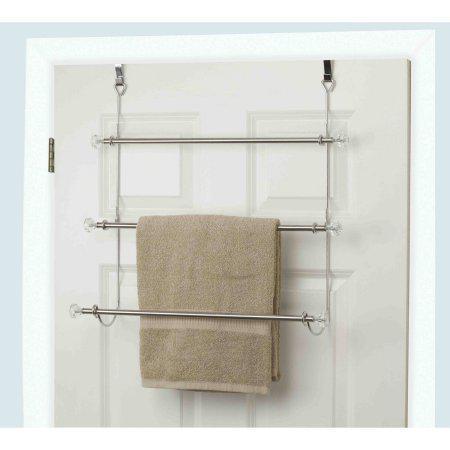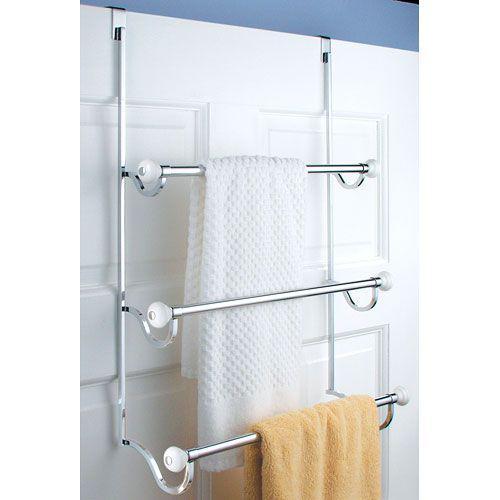The first image is the image on the left, the second image is the image on the right. Assess this claim about the two images: "Each image features an over-the-door chrome towel bar with at least 3 bars and at least one hanging towel.". Correct or not? Answer yes or no. Yes. The first image is the image on the left, the second image is the image on the right. Assess this claim about the two images: "The left and right image contains the same number of metal racks that can hold towels.". Correct or not? Answer yes or no. Yes. 